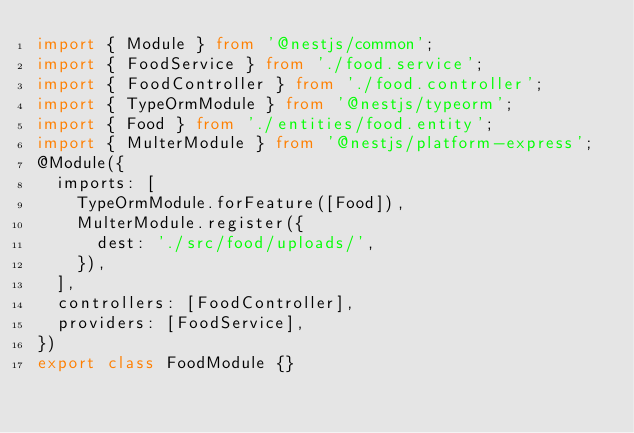Convert code to text. <code><loc_0><loc_0><loc_500><loc_500><_TypeScript_>import { Module } from '@nestjs/common';
import { FoodService } from './food.service';
import { FoodController } from './food.controller';
import { TypeOrmModule } from '@nestjs/typeorm';
import { Food } from './entities/food.entity';
import { MulterModule } from '@nestjs/platform-express';
@Module({
  imports: [
    TypeOrmModule.forFeature([Food]),
    MulterModule.register({
      dest: './src/food/uploads/',
    }),
  ],
  controllers: [FoodController],
  providers: [FoodService],
})
export class FoodModule {}
</code> 